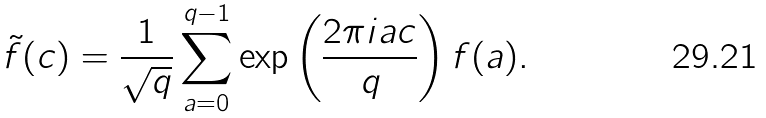Convert formula to latex. <formula><loc_0><loc_0><loc_500><loc_500>\tilde { f } ( c ) = \frac { 1 } { \sqrt { q } } \sum _ { a = 0 } ^ { q - 1 } \exp \left ( \frac { 2 \pi i a c } { q } \right ) f ( a ) .</formula> 